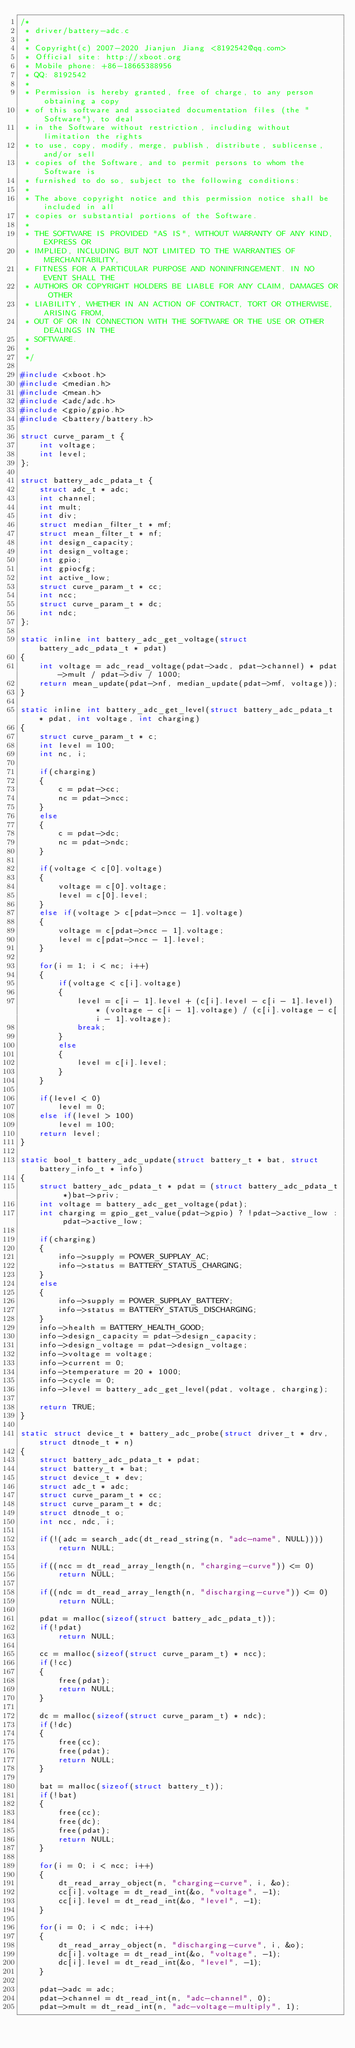<code> <loc_0><loc_0><loc_500><loc_500><_C_>/*
 * driver/battery-adc.c
 *
 * Copyright(c) 2007-2020 Jianjun Jiang <8192542@qq.com>
 * Official site: http://xboot.org
 * Mobile phone: +86-18665388956
 * QQ: 8192542
 *
 * Permission is hereby granted, free of charge, to any person obtaining a copy
 * of this software and associated documentation files (the "Software"), to deal
 * in the Software without restriction, including without limitation the rights
 * to use, copy, modify, merge, publish, distribute, sublicense, and/or sell
 * copies of the Software, and to permit persons to whom the Software is
 * furnished to do so, subject to the following conditions:
 *
 * The above copyright notice and this permission notice shall be included in all
 * copies or substantial portions of the Software.
 *
 * THE SOFTWARE IS PROVIDED "AS IS", WITHOUT WARRANTY OF ANY KIND, EXPRESS OR
 * IMPLIED, INCLUDING BUT NOT LIMITED TO THE WARRANTIES OF MERCHANTABILITY,
 * FITNESS FOR A PARTICULAR PURPOSE AND NONINFRINGEMENT. IN NO EVENT SHALL THE
 * AUTHORS OR COPYRIGHT HOLDERS BE LIABLE FOR ANY CLAIM, DAMAGES OR OTHER
 * LIABILITY, WHETHER IN AN ACTION OF CONTRACT, TORT OR OTHERWISE, ARISING FROM,
 * OUT OF OR IN CONNECTION WITH THE SOFTWARE OR THE USE OR OTHER DEALINGS IN THE
 * SOFTWARE.
 *
 */

#include <xboot.h>
#include <median.h>
#include <mean.h>
#include <adc/adc.h>
#include <gpio/gpio.h>
#include <battery/battery.h>

struct curve_param_t {
	int voltage;
	int level;
};

struct battery_adc_pdata_t {
	struct adc_t * adc;
	int channel;
	int mult;
	int div;
	struct median_filter_t * mf;
	struct mean_filter_t * nf;
	int design_capacity;
	int design_voltage;
	int gpio;
	int gpiocfg;
	int active_low;
	struct curve_param_t * cc;
	int ncc;
	struct curve_param_t * dc;
	int ndc;
};

static inline int battery_adc_get_voltage(struct battery_adc_pdata_t * pdat)
{
	int voltage = adc_read_voltage(pdat->adc, pdat->channel) * pdat->mult / pdat->div / 1000;
	return mean_update(pdat->nf, median_update(pdat->mf, voltage));
}

static inline int battery_adc_get_level(struct battery_adc_pdata_t * pdat, int voltage, int charging)
{
	struct curve_param_t * c;
	int level = 100;
	int nc, i;

	if(charging)
	{
		c = pdat->cc;
		nc = pdat->ncc;
	}
	else
	{
		c = pdat->dc;
		nc = pdat->ndc;
	}

	if(voltage < c[0].voltage)
	{
		voltage = c[0].voltage;
		level = c[0].level;
	}
	else if(voltage > c[pdat->ncc - 1].voltage)
	{
		voltage = c[pdat->ncc - 1].voltage;
		level = c[pdat->ncc - 1].level;
	}

	for(i = 1; i < nc; i++)
	{
		if(voltage < c[i].voltage)
		{
			level = c[i - 1].level + (c[i].level - c[i - 1].level) * (voltage - c[i - 1].voltage) / (c[i].voltage - c[i - 1].voltage);
			break;
		}
		else
		{
			level = c[i].level;
		}
	}

	if(level < 0)
		level = 0;
	else if(level > 100)
		level = 100;
	return level;
}

static bool_t battery_adc_update(struct battery_t * bat, struct battery_info_t * info)
{
	struct battery_adc_pdata_t * pdat = (struct battery_adc_pdata_t *)bat->priv;
	int voltage = battery_adc_get_voltage(pdat);
	int charging = gpio_get_value(pdat->gpio) ? !pdat->active_low : pdat->active_low;

	if(charging)
	{
		info->supply = POWER_SUPPLAY_AC;
		info->status = BATTERY_STATUS_CHARGING;
	}
	else
	{
		info->supply = POWER_SUPPLAY_BATTERY;
		info->status = BATTERY_STATUS_DISCHARGING;
	}
	info->health = BATTERY_HEALTH_GOOD;
	info->design_capacity = pdat->design_capacity;
	info->design_voltage = pdat->design_voltage;
	info->voltage = voltage;
	info->current = 0;
	info->temperature = 20 * 1000;
	info->cycle = 0;
	info->level = battery_adc_get_level(pdat, voltage, charging);

	return TRUE;
}

static struct device_t * battery_adc_probe(struct driver_t * drv, struct dtnode_t * n)
{
	struct battery_adc_pdata_t * pdat;
	struct battery_t * bat;
	struct device_t * dev;
	struct adc_t * adc;
	struct curve_param_t * cc;
	struct curve_param_t * dc;
	struct dtnode_t o;
	int ncc, ndc, i;

	if(!(adc = search_adc(dt_read_string(n, "adc-name", NULL))))
		return NULL;

	if((ncc = dt_read_array_length(n, "charging-curve")) <= 0)
		return NULL;

	if((ndc = dt_read_array_length(n, "discharging-curve")) <= 0)
		return NULL;

	pdat = malloc(sizeof(struct battery_adc_pdata_t));
	if(!pdat)
		return NULL;

	cc = malloc(sizeof(struct curve_param_t) * ncc);
	if(!cc)
	{
		free(pdat);
		return NULL;
	}

	dc = malloc(sizeof(struct curve_param_t) * ndc);
	if(!dc)
	{
		free(cc);
		free(pdat);
		return NULL;
	}

	bat = malloc(sizeof(struct battery_t));
	if(!bat)
	{
		free(cc);
		free(dc);
		free(pdat);
		return NULL;
	}

	for(i = 0; i < ncc; i++)
	{
		dt_read_array_object(n, "charging-curve", i, &o);
		cc[i].voltage = dt_read_int(&o, "voltage", -1);
		cc[i].level = dt_read_int(&o, "level", -1);
	}

	for(i = 0; i < ndc; i++)
	{
		dt_read_array_object(n, "discharging-curve", i, &o);
		dc[i].voltage = dt_read_int(&o, "voltage", -1);
		dc[i].level = dt_read_int(&o, "level", -1);
	}

	pdat->adc = adc;
	pdat->channel = dt_read_int(n, "adc-channel", 0);
	pdat->mult = dt_read_int(n, "adc-voltage-multiply", 1);</code> 